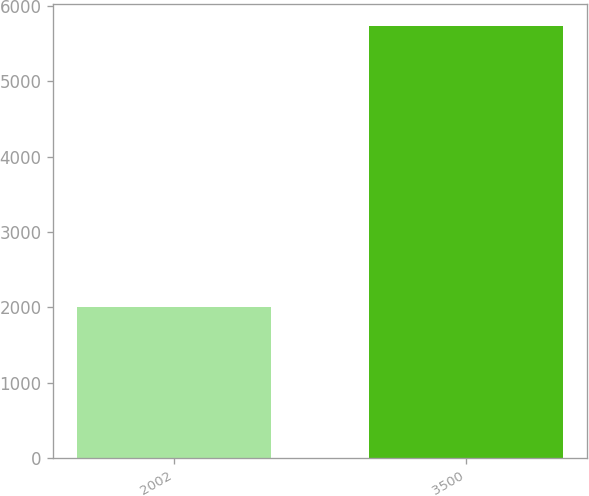<chart> <loc_0><loc_0><loc_500><loc_500><bar_chart><fcel>2002<fcel>3500<nl><fcel>2000<fcel>5734<nl></chart> 